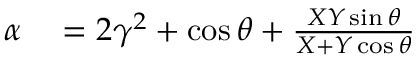Convert formula to latex. <formula><loc_0><loc_0><loc_500><loc_500>\begin{array} { r l } { \alpha } & = 2 \gamma ^ { 2 } + \cos \theta + \frac { X Y \sin \theta } { X + Y \cos \theta } } \end{array}</formula> 